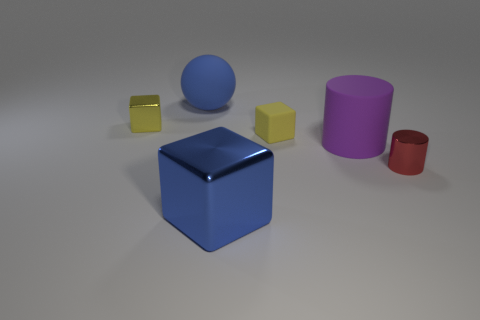Add 2 small yellow shiny blocks. How many objects exist? 8 Subtract all balls. How many objects are left? 5 Add 4 small brown rubber cubes. How many small brown rubber cubes exist? 4 Subtract 0 yellow cylinders. How many objects are left? 6 Subtract all small brown spheres. Subtract all purple rubber cylinders. How many objects are left? 5 Add 3 big spheres. How many big spheres are left? 4 